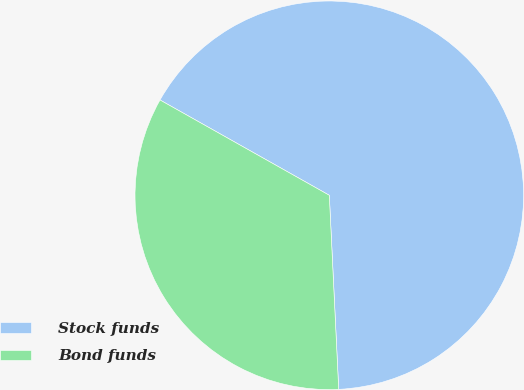<chart> <loc_0><loc_0><loc_500><loc_500><pie_chart><fcel>Stock funds<fcel>Bond funds<nl><fcel>66.07%<fcel>33.93%<nl></chart> 